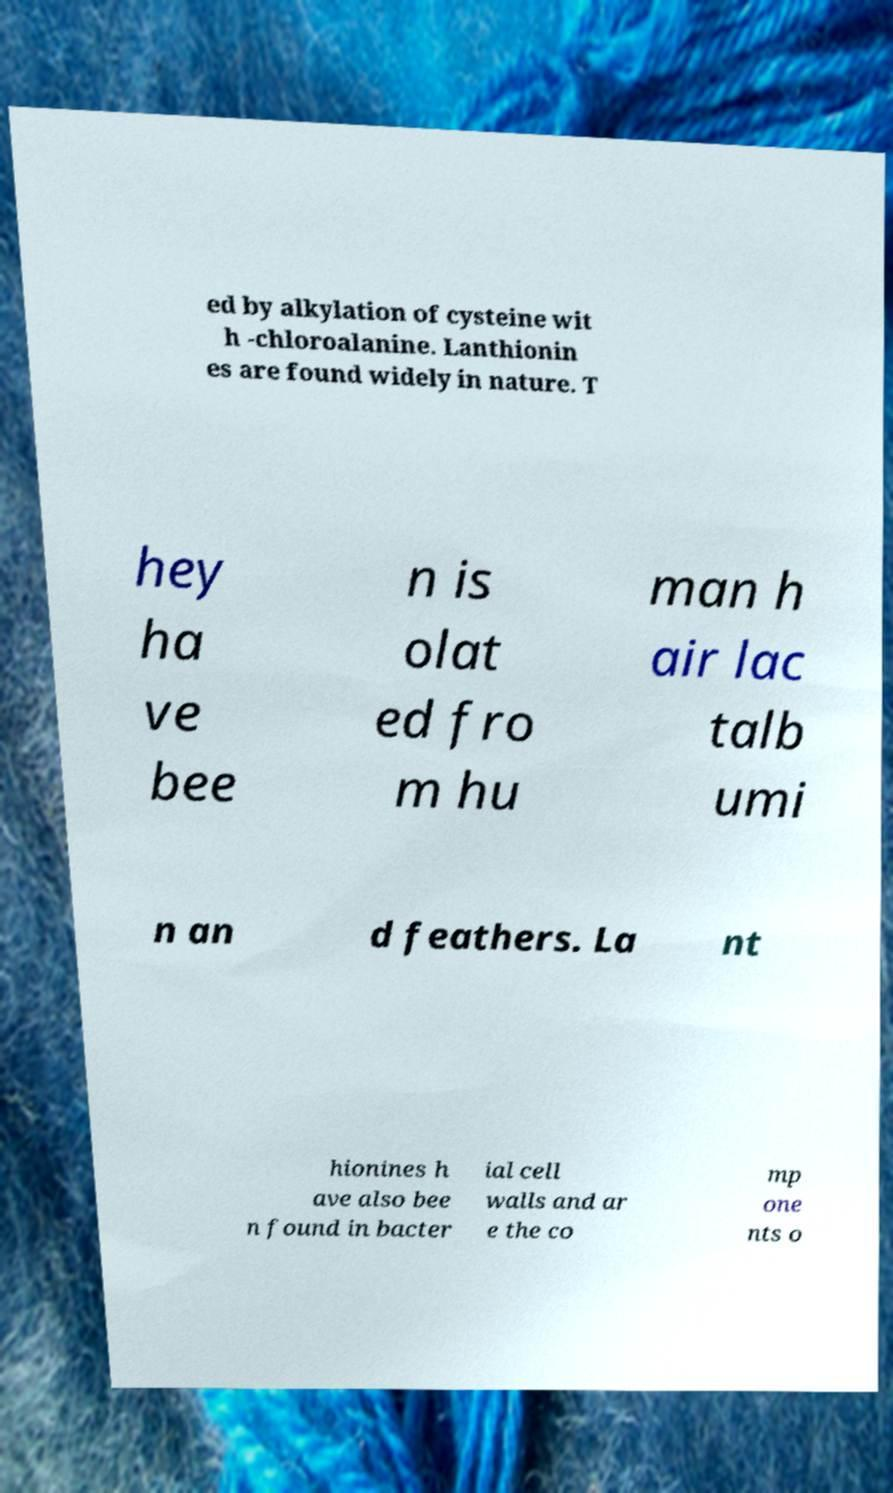There's text embedded in this image that I need extracted. Can you transcribe it verbatim? ed by alkylation of cysteine wit h -chloroalanine. Lanthionin es are found widely in nature. T hey ha ve bee n is olat ed fro m hu man h air lac talb umi n an d feathers. La nt hionines h ave also bee n found in bacter ial cell walls and ar e the co mp one nts o 